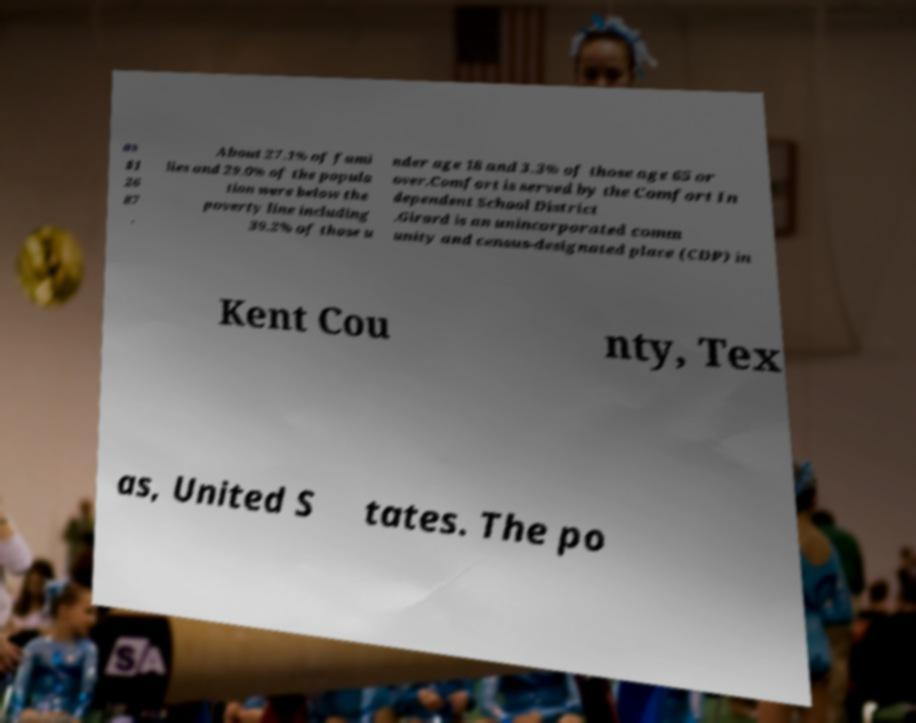I need the written content from this picture converted into text. Can you do that? as $1 26 87 . About 27.1% of fami lies and 29.0% of the popula tion were below the poverty line including 39.2% of those u nder age 18 and 3.3% of those age 65 or over.Comfort is served by the Comfort In dependent School District .Girard is an unincorporated comm unity and census-designated place (CDP) in Kent Cou nty, Tex as, United S tates. The po 